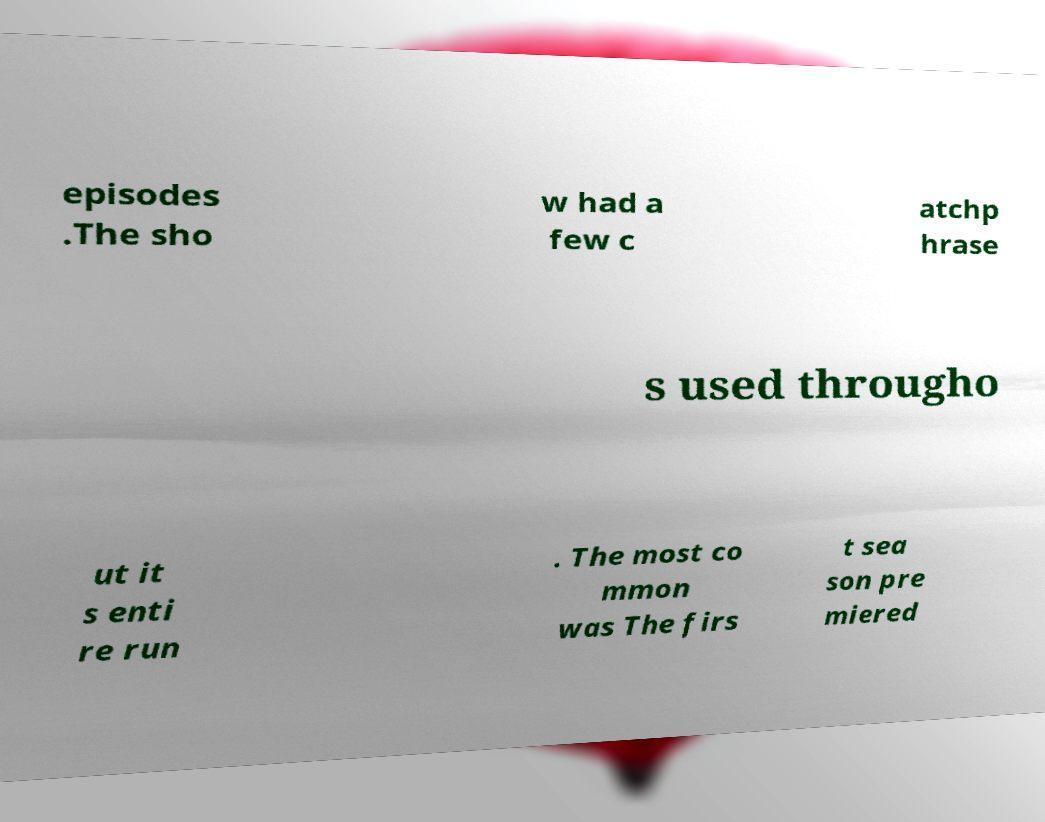Please identify and transcribe the text found in this image. episodes .The sho w had a few c atchp hrase s used througho ut it s enti re run . The most co mmon was The firs t sea son pre miered 